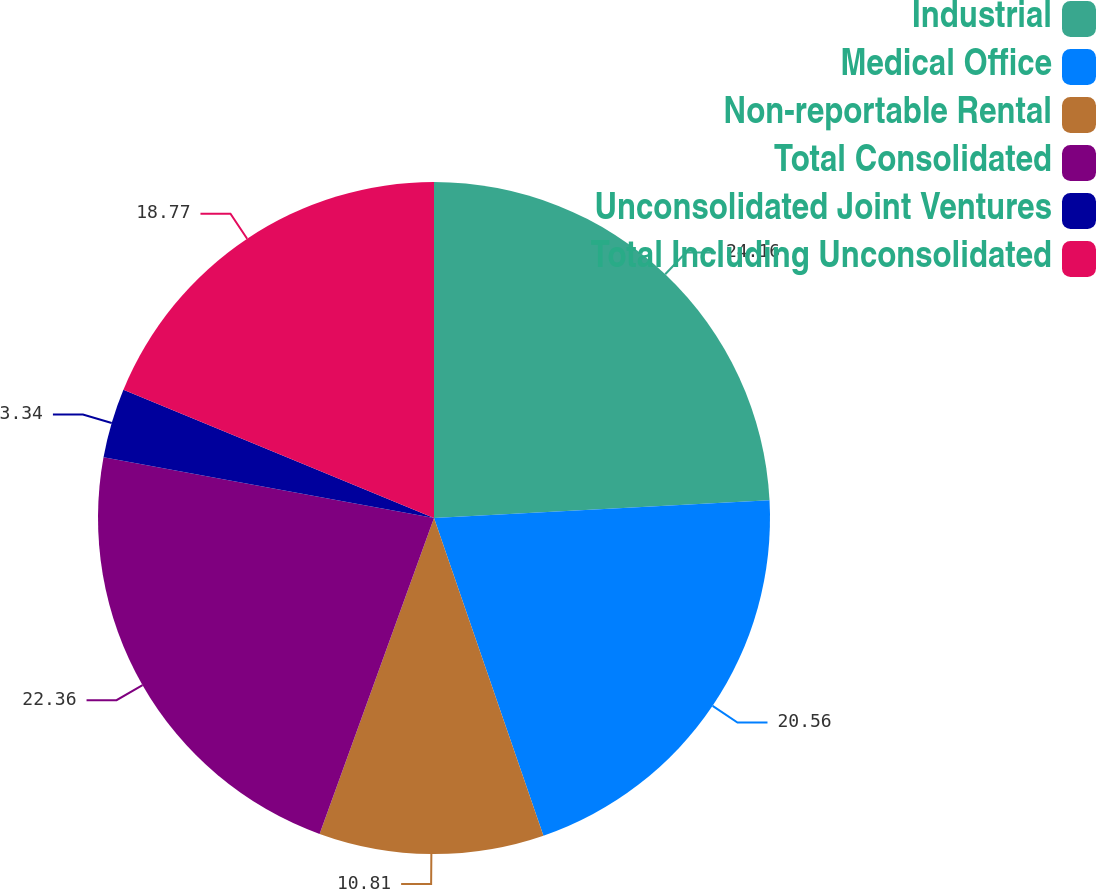Convert chart to OTSL. <chart><loc_0><loc_0><loc_500><loc_500><pie_chart><fcel>Industrial<fcel>Medical Office<fcel>Non-reportable Rental<fcel>Total Consolidated<fcel>Unconsolidated Joint Ventures<fcel>Total Including Unconsolidated<nl><fcel>24.16%<fcel>20.56%<fcel>10.81%<fcel>22.36%<fcel>3.34%<fcel>18.77%<nl></chart> 